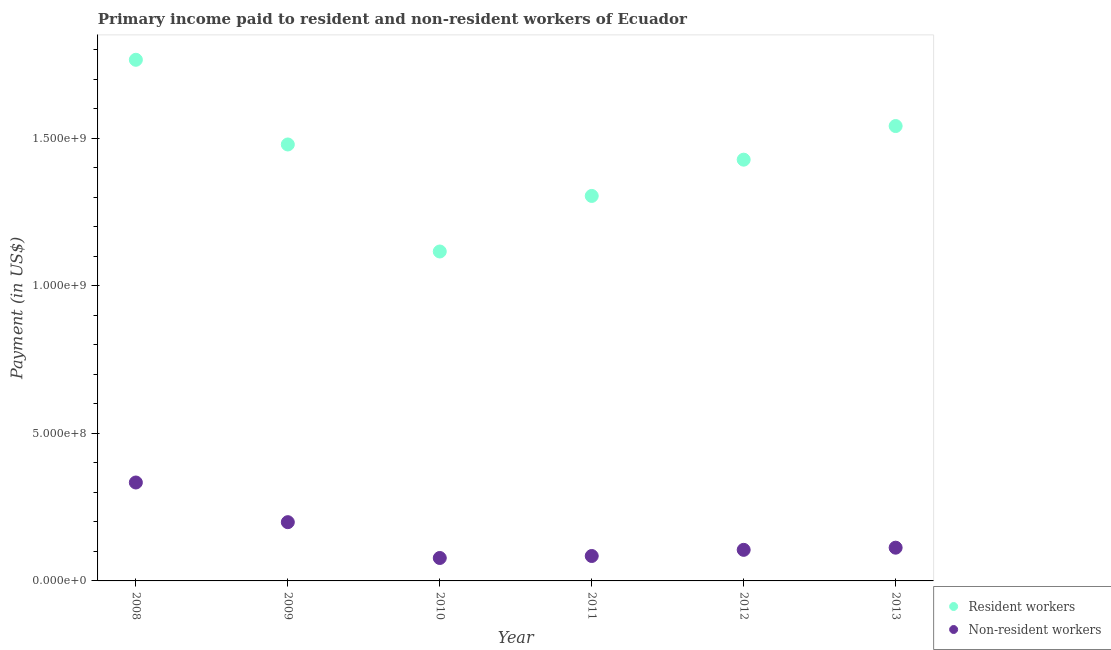Is the number of dotlines equal to the number of legend labels?
Ensure brevity in your answer.  Yes. What is the payment made to resident workers in 2008?
Keep it short and to the point. 1.77e+09. Across all years, what is the maximum payment made to non-resident workers?
Your response must be concise. 3.34e+08. Across all years, what is the minimum payment made to resident workers?
Ensure brevity in your answer.  1.12e+09. What is the total payment made to non-resident workers in the graph?
Your answer should be very brief. 9.13e+08. What is the difference between the payment made to resident workers in 2009 and that in 2012?
Provide a succinct answer. 5.15e+07. What is the difference between the payment made to resident workers in 2010 and the payment made to non-resident workers in 2012?
Offer a very short reply. 1.01e+09. What is the average payment made to resident workers per year?
Your response must be concise. 1.44e+09. In the year 2011, what is the difference between the payment made to non-resident workers and payment made to resident workers?
Provide a short and direct response. -1.22e+09. What is the ratio of the payment made to non-resident workers in 2008 to that in 2011?
Keep it short and to the point. 3.95. Is the payment made to resident workers in 2010 less than that in 2011?
Ensure brevity in your answer.  Yes. Is the difference between the payment made to resident workers in 2009 and 2011 greater than the difference between the payment made to non-resident workers in 2009 and 2011?
Your answer should be compact. Yes. What is the difference between the highest and the second highest payment made to resident workers?
Provide a succinct answer. 2.25e+08. What is the difference between the highest and the lowest payment made to non-resident workers?
Offer a very short reply. 2.56e+08. Does the payment made to resident workers monotonically increase over the years?
Give a very brief answer. No. Is the payment made to non-resident workers strictly greater than the payment made to resident workers over the years?
Give a very brief answer. No. How many dotlines are there?
Offer a very short reply. 2. How many years are there in the graph?
Offer a terse response. 6. Does the graph contain grids?
Ensure brevity in your answer.  No. Where does the legend appear in the graph?
Your answer should be very brief. Bottom right. What is the title of the graph?
Offer a terse response. Primary income paid to resident and non-resident workers of Ecuador. Does "Travel Items" appear as one of the legend labels in the graph?
Provide a short and direct response. No. What is the label or title of the X-axis?
Provide a short and direct response. Year. What is the label or title of the Y-axis?
Make the answer very short. Payment (in US$). What is the Payment (in US$) in Resident workers in 2008?
Offer a very short reply. 1.77e+09. What is the Payment (in US$) in Non-resident workers in 2008?
Provide a succinct answer. 3.34e+08. What is the Payment (in US$) of Resident workers in 2009?
Your response must be concise. 1.48e+09. What is the Payment (in US$) of Non-resident workers in 2009?
Your answer should be compact. 1.99e+08. What is the Payment (in US$) of Resident workers in 2010?
Offer a terse response. 1.12e+09. What is the Payment (in US$) of Non-resident workers in 2010?
Provide a short and direct response. 7.77e+07. What is the Payment (in US$) in Resident workers in 2011?
Your answer should be compact. 1.30e+09. What is the Payment (in US$) in Non-resident workers in 2011?
Give a very brief answer. 8.45e+07. What is the Payment (in US$) of Resident workers in 2012?
Provide a short and direct response. 1.43e+09. What is the Payment (in US$) of Non-resident workers in 2012?
Ensure brevity in your answer.  1.05e+08. What is the Payment (in US$) in Resident workers in 2013?
Your response must be concise. 1.54e+09. What is the Payment (in US$) in Non-resident workers in 2013?
Offer a very short reply. 1.13e+08. Across all years, what is the maximum Payment (in US$) in Resident workers?
Give a very brief answer. 1.77e+09. Across all years, what is the maximum Payment (in US$) of Non-resident workers?
Offer a terse response. 3.34e+08. Across all years, what is the minimum Payment (in US$) in Resident workers?
Keep it short and to the point. 1.12e+09. Across all years, what is the minimum Payment (in US$) of Non-resident workers?
Give a very brief answer. 7.77e+07. What is the total Payment (in US$) of Resident workers in the graph?
Provide a succinct answer. 8.63e+09. What is the total Payment (in US$) of Non-resident workers in the graph?
Offer a terse response. 9.13e+08. What is the difference between the Payment (in US$) of Resident workers in 2008 and that in 2009?
Your answer should be compact. 2.87e+08. What is the difference between the Payment (in US$) in Non-resident workers in 2008 and that in 2009?
Offer a terse response. 1.34e+08. What is the difference between the Payment (in US$) in Resident workers in 2008 and that in 2010?
Keep it short and to the point. 6.50e+08. What is the difference between the Payment (in US$) in Non-resident workers in 2008 and that in 2010?
Give a very brief answer. 2.56e+08. What is the difference between the Payment (in US$) of Resident workers in 2008 and that in 2011?
Make the answer very short. 4.61e+08. What is the difference between the Payment (in US$) in Non-resident workers in 2008 and that in 2011?
Your answer should be compact. 2.49e+08. What is the difference between the Payment (in US$) of Resident workers in 2008 and that in 2012?
Keep it short and to the point. 3.38e+08. What is the difference between the Payment (in US$) of Non-resident workers in 2008 and that in 2012?
Provide a short and direct response. 2.28e+08. What is the difference between the Payment (in US$) of Resident workers in 2008 and that in 2013?
Your answer should be compact. 2.25e+08. What is the difference between the Payment (in US$) in Non-resident workers in 2008 and that in 2013?
Your answer should be compact. 2.21e+08. What is the difference between the Payment (in US$) of Resident workers in 2009 and that in 2010?
Offer a very short reply. 3.63e+08. What is the difference between the Payment (in US$) in Non-resident workers in 2009 and that in 2010?
Provide a short and direct response. 1.21e+08. What is the difference between the Payment (in US$) in Resident workers in 2009 and that in 2011?
Offer a terse response. 1.74e+08. What is the difference between the Payment (in US$) in Non-resident workers in 2009 and that in 2011?
Offer a very short reply. 1.15e+08. What is the difference between the Payment (in US$) of Resident workers in 2009 and that in 2012?
Your response must be concise. 5.15e+07. What is the difference between the Payment (in US$) in Non-resident workers in 2009 and that in 2012?
Ensure brevity in your answer.  9.38e+07. What is the difference between the Payment (in US$) in Resident workers in 2009 and that in 2013?
Offer a very short reply. -6.24e+07. What is the difference between the Payment (in US$) of Non-resident workers in 2009 and that in 2013?
Offer a terse response. 8.64e+07. What is the difference between the Payment (in US$) of Resident workers in 2010 and that in 2011?
Make the answer very short. -1.88e+08. What is the difference between the Payment (in US$) of Non-resident workers in 2010 and that in 2011?
Provide a succinct answer. -6.75e+06. What is the difference between the Payment (in US$) in Resident workers in 2010 and that in 2012?
Your answer should be compact. -3.11e+08. What is the difference between the Payment (in US$) in Non-resident workers in 2010 and that in 2012?
Your answer should be compact. -2.76e+07. What is the difference between the Payment (in US$) of Resident workers in 2010 and that in 2013?
Your response must be concise. -4.25e+08. What is the difference between the Payment (in US$) in Non-resident workers in 2010 and that in 2013?
Give a very brief answer. -3.49e+07. What is the difference between the Payment (in US$) of Resident workers in 2011 and that in 2012?
Offer a very short reply. -1.23e+08. What is the difference between the Payment (in US$) in Non-resident workers in 2011 and that in 2012?
Provide a short and direct response. -2.08e+07. What is the difference between the Payment (in US$) of Resident workers in 2011 and that in 2013?
Make the answer very short. -2.37e+08. What is the difference between the Payment (in US$) in Non-resident workers in 2011 and that in 2013?
Your answer should be compact. -2.82e+07. What is the difference between the Payment (in US$) of Resident workers in 2012 and that in 2013?
Give a very brief answer. -1.14e+08. What is the difference between the Payment (in US$) of Non-resident workers in 2012 and that in 2013?
Provide a short and direct response. -7.33e+06. What is the difference between the Payment (in US$) of Resident workers in 2008 and the Payment (in US$) of Non-resident workers in 2009?
Your answer should be compact. 1.57e+09. What is the difference between the Payment (in US$) in Resident workers in 2008 and the Payment (in US$) in Non-resident workers in 2010?
Offer a terse response. 1.69e+09. What is the difference between the Payment (in US$) of Resident workers in 2008 and the Payment (in US$) of Non-resident workers in 2011?
Your response must be concise. 1.68e+09. What is the difference between the Payment (in US$) of Resident workers in 2008 and the Payment (in US$) of Non-resident workers in 2012?
Give a very brief answer. 1.66e+09. What is the difference between the Payment (in US$) in Resident workers in 2008 and the Payment (in US$) in Non-resident workers in 2013?
Your answer should be very brief. 1.65e+09. What is the difference between the Payment (in US$) of Resident workers in 2009 and the Payment (in US$) of Non-resident workers in 2010?
Provide a succinct answer. 1.40e+09. What is the difference between the Payment (in US$) of Resident workers in 2009 and the Payment (in US$) of Non-resident workers in 2011?
Keep it short and to the point. 1.39e+09. What is the difference between the Payment (in US$) of Resident workers in 2009 and the Payment (in US$) of Non-resident workers in 2012?
Provide a succinct answer. 1.37e+09. What is the difference between the Payment (in US$) of Resident workers in 2009 and the Payment (in US$) of Non-resident workers in 2013?
Your response must be concise. 1.37e+09. What is the difference between the Payment (in US$) in Resident workers in 2010 and the Payment (in US$) in Non-resident workers in 2011?
Offer a very short reply. 1.03e+09. What is the difference between the Payment (in US$) of Resident workers in 2010 and the Payment (in US$) of Non-resident workers in 2012?
Offer a terse response. 1.01e+09. What is the difference between the Payment (in US$) in Resident workers in 2010 and the Payment (in US$) in Non-resident workers in 2013?
Keep it short and to the point. 1.00e+09. What is the difference between the Payment (in US$) of Resident workers in 2011 and the Payment (in US$) of Non-resident workers in 2012?
Your answer should be compact. 1.20e+09. What is the difference between the Payment (in US$) of Resident workers in 2011 and the Payment (in US$) of Non-resident workers in 2013?
Offer a terse response. 1.19e+09. What is the difference between the Payment (in US$) in Resident workers in 2012 and the Payment (in US$) in Non-resident workers in 2013?
Make the answer very short. 1.31e+09. What is the average Payment (in US$) in Resident workers per year?
Keep it short and to the point. 1.44e+09. What is the average Payment (in US$) in Non-resident workers per year?
Offer a terse response. 1.52e+08. In the year 2008, what is the difference between the Payment (in US$) in Resident workers and Payment (in US$) in Non-resident workers?
Offer a very short reply. 1.43e+09. In the year 2009, what is the difference between the Payment (in US$) in Resident workers and Payment (in US$) in Non-resident workers?
Make the answer very short. 1.28e+09. In the year 2010, what is the difference between the Payment (in US$) of Resident workers and Payment (in US$) of Non-resident workers?
Offer a terse response. 1.04e+09. In the year 2011, what is the difference between the Payment (in US$) of Resident workers and Payment (in US$) of Non-resident workers?
Provide a short and direct response. 1.22e+09. In the year 2012, what is the difference between the Payment (in US$) in Resident workers and Payment (in US$) in Non-resident workers?
Your answer should be compact. 1.32e+09. In the year 2013, what is the difference between the Payment (in US$) of Resident workers and Payment (in US$) of Non-resident workers?
Your answer should be compact. 1.43e+09. What is the ratio of the Payment (in US$) of Resident workers in 2008 to that in 2009?
Keep it short and to the point. 1.19. What is the ratio of the Payment (in US$) of Non-resident workers in 2008 to that in 2009?
Give a very brief answer. 1.68. What is the ratio of the Payment (in US$) in Resident workers in 2008 to that in 2010?
Your answer should be compact. 1.58. What is the ratio of the Payment (in US$) in Non-resident workers in 2008 to that in 2010?
Offer a terse response. 4.29. What is the ratio of the Payment (in US$) in Resident workers in 2008 to that in 2011?
Provide a succinct answer. 1.35. What is the ratio of the Payment (in US$) in Non-resident workers in 2008 to that in 2011?
Make the answer very short. 3.95. What is the ratio of the Payment (in US$) of Resident workers in 2008 to that in 2012?
Ensure brevity in your answer.  1.24. What is the ratio of the Payment (in US$) of Non-resident workers in 2008 to that in 2012?
Provide a short and direct response. 3.17. What is the ratio of the Payment (in US$) of Resident workers in 2008 to that in 2013?
Your answer should be very brief. 1.15. What is the ratio of the Payment (in US$) in Non-resident workers in 2008 to that in 2013?
Keep it short and to the point. 2.96. What is the ratio of the Payment (in US$) of Resident workers in 2009 to that in 2010?
Your answer should be compact. 1.32. What is the ratio of the Payment (in US$) in Non-resident workers in 2009 to that in 2010?
Your answer should be very brief. 2.56. What is the ratio of the Payment (in US$) in Resident workers in 2009 to that in 2011?
Offer a terse response. 1.13. What is the ratio of the Payment (in US$) in Non-resident workers in 2009 to that in 2011?
Your answer should be compact. 2.36. What is the ratio of the Payment (in US$) in Resident workers in 2009 to that in 2012?
Make the answer very short. 1.04. What is the ratio of the Payment (in US$) of Non-resident workers in 2009 to that in 2012?
Offer a terse response. 1.89. What is the ratio of the Payment (in US$) of Resident workers in 2009 to that in 2013?
Your answer should be compact. 0.96. What is the ratio of the Payment (in US$) of Non-resident workers in 2009 to that in 2013?
Your response must be concise. 1.77. What is the ratio of the Payment (in US$) in Resident workers in 2010 to that in 2011?
Keep it short and to the point. 0.86. What is the ratio of the Payment (in US$) in Non-resident workers in 2010 to that in 2011?
Your answer should be very brief. 0.92. What is the ratio of the Payment (in US$) in Resident workers in 2010 to that in 2012?
Your response must be concise. 0.78. What is the ratio of the Payment (in US$) in Non-resident workers in 2010 to that in 2012?
Give a very brief answer. 0.74. What is the ratio of the Payment (in US$) of Resident workers in 2010 to that in 2013?
Your answer should be very brief. 0.72. What is the ratio of the Payment (in US$) of Non-resident workers in 2010 to that in 2013?
Ensure brevity in your answer.  0.69. What is the ratio of the Payment (in US$) of Resident workers in 2011 to that in 2012?
Give a very brief answer. 0.91. What is the ratio of the Payment (in US$) in Non-resident workers in 2011 to that in 2012?
Give a very brief answer. 0.8. What is the ratio of the Payment (in US$) in Resident workers in 2011 to that in 2013?
Provide a succinct answer. 0.85. What is the ratio of the Payment (in US$) of Non-resident workers in 2011 to that in 2013?
Keep it short and to the point. 0.75. What is the ratio of the Payment (in US$) in Resident workers in 2012 to that in 2013?
Ensure brevity in your answer.  0.93. What is the ratio of the Payment (in US$) in Non-resident workers in 2012 to that in 2013?
Make the answer very short. 0.94. What is the difference between the highest and the second highest Payment (in US$) of Resident workers?
Your response must be concise. 2.25e+08. What is the difference between the highest and the second highest Payment (in US$) in Non-resident workers?
Your answer should be compact. 1.34e+08. What is the difference between the highest and the lowest Payment (in US$) in Resident workers?
Your answer should be very brief. 6.50e+08. What is the difference between the highest and the lowest Payment (in US$) in Non-resident workers?
Your response must be concise. 2.56e+08. 